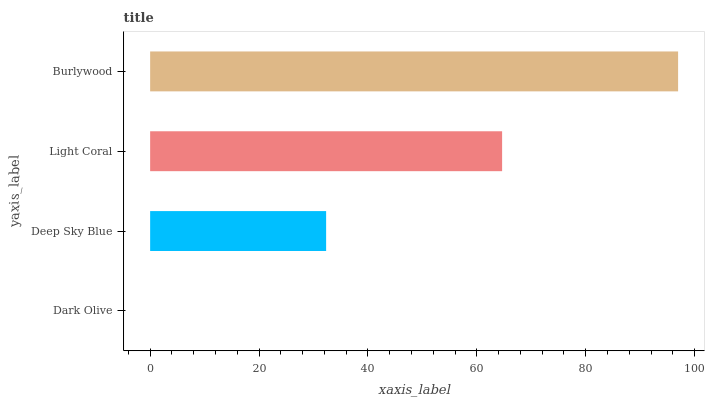Is Dark Olive the minimum?
Answer yes or no. Yes. Is Burlywood the maximum?
Answer yes or no. Yes. Is Deep Sky Blue the minimum?
Answer yes or no. No. Is Deep Sky Blue the maximum?
Answer yes or no. No. Is Deep Sky Blue greater than Dark Olive?
Answer yes or no. Yes. Is Dark Olive less than Deep Sky Blue?
Answer yes or no. Yes. Is Dark Olive greater than Deep Sky Blue?
Answer yes or no. No. Is Deep Sky Blue less than Dark Olive?
Answer yes or no. No. Is Light Coral the high median?
Answer yes or no. Yes. Is Deep Sky Blue the low median?
Answer yes or no. Yes. Is Dark Olive the high median?
Answer yes or no. No. Is Burlywood the low median?
Answer yes or no. No. 